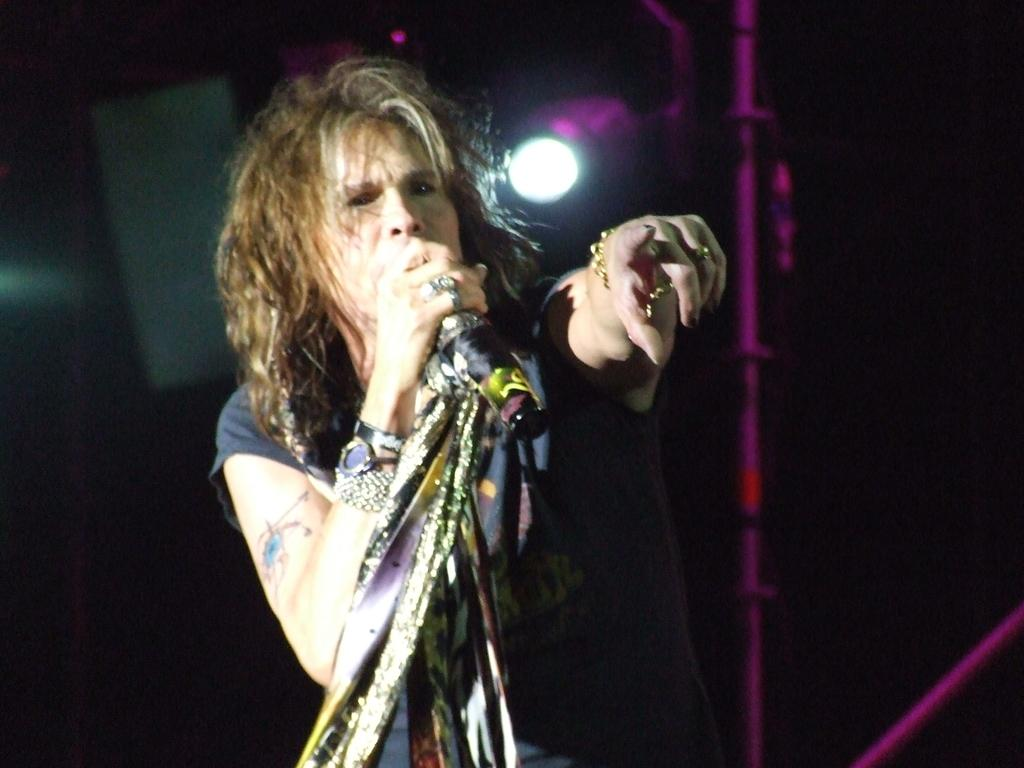What is the main subject of the image? The main subject of the image is a woman. What is the woman holding in her hand? The woman is holding a mic in her hand. What can be seen in the background of the image? There is a light in the background of the image. How many pigs are visible in the image? There are no pigs present in the image. What type of smash can be seen happening in the image? There is no smash happening in the image. What part of the woman's face is highlighted in the image? The facts provided do not mention any specific part of the woman's face being highlighted. 